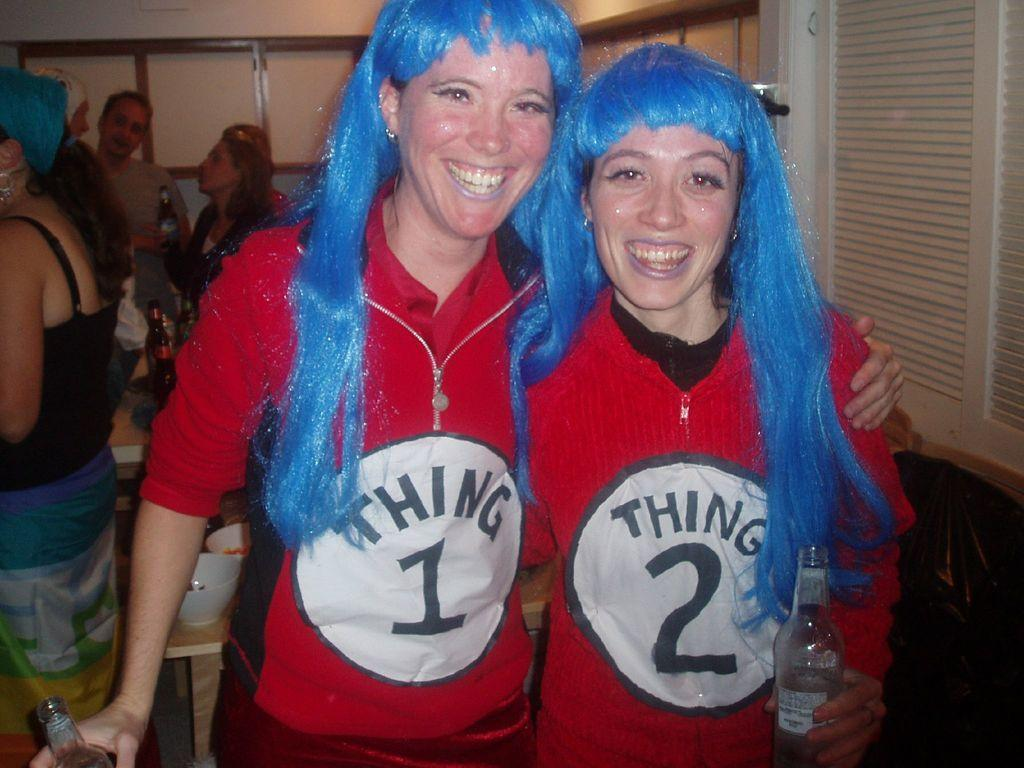<image>
Share a concise interpretation of the image provided. Two women dressed up as Thing 1 and Thing 2. 